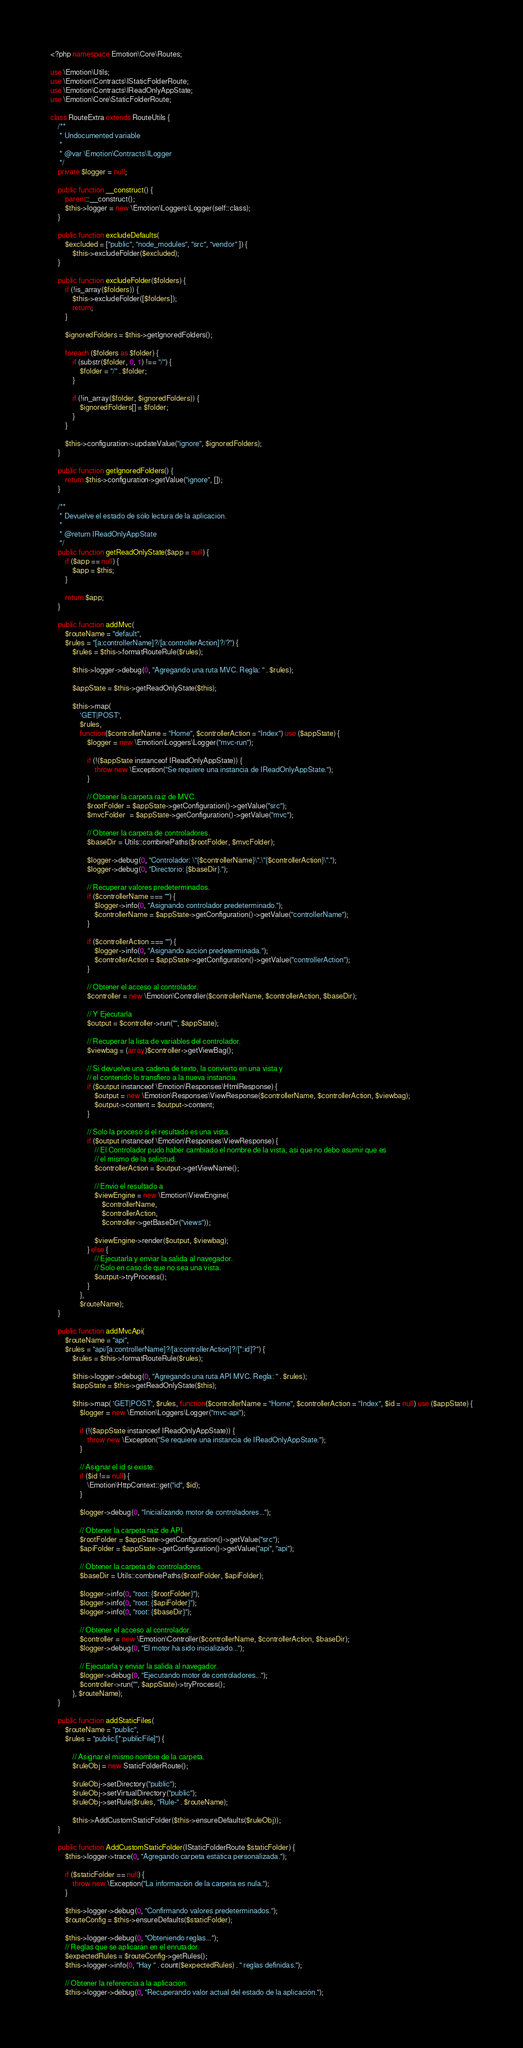<code> <loc_0><loc_0><loc_500><loc_500><_PHP_><?php namespace Emotion\Core\Routes;

use \Emotion\Utils;
use \Emotion\Contracts\IStaticFolderRoute;
use \Emotion\Contracts\IReadOnlyAppState;
use \Emotion\Core\StaticFolderRoute;

class RouteExtra extends RouteUtils {
    /**
     * Undocumented variable
     *
     * @var \Emotion\Contracts\ILogger
     */
    private $logger = null;

    public function __construct() {
        parent::__construct();
        $this->logger = new \Emotion\Loggers\Logger(self::class);
    }

    public function excludeDefaults(
        $excluded = ["public", "node_modules", "src", "vendor" ]) {
            $this->excludeFolder($excluded);
    }
    
    public function excludeFolder($folders) {
        if (!is_array($folders)) {
            $this->excludeFolder([$folders]);
            return;
        }
        
        $ignoredFolders = $this->getIgnoredFolders();
        
        foreach ($folders as $folder) {
            if (substr($folder, 0, 1) !== "/") {
                $folder = "/" . $folder;
            }
            
            if (!in_array($folder, $ignoredFolders)) {
                $ignoredFolders[] = $folder;
            }
        }
        
        $this->configuration->updateValue("ignore", $ignoredFolders);
    }
    
    public function getIgnoredFolders() {
        return $this->configuration->getValue("ignore", []);
    }

    /**
     * Devuelve el estado de sólo lectura de la aplicación.
     *
     * @return IReadOnlyAppState
     */
    public function getReadOnlyState($app = null) {
        if ($app == null) {
            $app = $this;
        }

        return $app;
    }
    
    public function addMvc(
        $routeName = "default",
        $rules = "[a:controllerName]?/[a:controllerAction]?/?") {
            $rules = $this->formatRouteRule($rules);

            $this->logger->debug(0, "Agregando una ruta MVC. Regla: " . $rules);

            $appState = $this->getReadOnlyState($this);

            $this->map(
                'GET|POST',
                $rules, 
                function($controllerName = "Home", $controllerAction = "Index") use ($appState) {
                    $logger = new \Emotion\Loggers\Logger("mvc-run");

                    if (!($appState instanceof IReadOnlyAppState)) {
                        throw new \Exception("Se requiere una instancia de IReadOnlyAppState.");
                    }

                    // Obtener la carpeta raíz de MVC.
                    $rootFolder = $appState->getConfiguration()->getValue("src");
                    $mvcFolder  = $appState->getConfiguration()->getValue("mvc");

                    // Obtener la carpeta de controladores.
                    $baseDir = Utils::combinePaths($rootFolder, $mvcFolder);

                    $logger->debug(0, "Controlador: \"{$controllerName}\".\"{$controllerAction}\".");
                    $logger->debug(0, "Directorio: {$baseDir}.");

                    // Recuperar valores predeterminados.
                    if ($controllerName === "") {
                        $logger->info(0, "Asignando controlador predeterminado.");
                        $controllerName = $appState->getConfiguration()->getValue("controllerName");
                    }

                    if ($controllerAction === "") {
                        $logger->info(0, "Asignando acción predeterminada.");
                        $controllerAction = $appState->getConfiguration()->getValue("controllerAction");
                    }

                    // Obtener el acceso al controlador.
                    $controller = new \Emotion\Controller($controllerName, $controllerAction, $baseDir);

                    // Y Ejecutarla
                    $output = $controller->run("", $appState);
                
                    // Recuperar la lista de variables del controlador.
                    $viewbag = (array)$controller->getViewBag();
                    
                    // Si devuelve una cadena de texto, la convierto en una vista y
                    // el contenido lo transfiero a la nueva instancia.
                    if ($output instanceof \Emotion\Responses\HtmlResponse) {
                        $output = new \Emotion\Responses\ViewResponse($controllerName, $controllerAction, $viewbag);
                        $output->content = $output->content;
                    }
                    
                    // Solo la proceso si el resultado es una vista.
                    if ($output instanceof \Emotion\Responses\ViewResponse) {
                        // El Controlador pudo haber cambiado el nombre de la vista, así que no debo asumir que es
                        // el mismo de la solicitud.
                        $controllerAction = $output->getViewName();

                        // Envio el resultado a 
                        $viewEngine = new \Emotion\ViewEngine(
                            $controllerName,
                            $controllerAction,
                            $controller->getBaseDir("views"));
                
                        $viewEngine->render($output, $viewbag);
                    } else {
                        // Ejecutarla y enviar la salida al navegador.
                        // Solo en caso de que no sea una vista.
                        $output->tryProcess();
                    }             
                },
                $routeName);
    }

    public function addMvcApi(
        $routeName = "api",
        $rules = "api/[a:controllerName]?/[a:controllerAction]?/[*:id]?") {
            $rules = $this->formatRouteRule($rules);

            $this->logger->debug(0, "Agregando una ruta API MVC. Regla: " . $rules);
            $appState = $this->getReadOnlyState($this);

            $this->map( 'GET|POST', $rules, function($controllerName = "Home", $controllerAction = "Index", $id = null) use ($appState) {
                $logger = new \Emotion\Loggers\Logger("mvc-api");
                
                if (!($appState instanceof IReadOnlyAppState)) {
                    throw new \Exception("Se requiere una instancia de IReadOnlyAppState.");
                }

                // Asignar el id si existe.
                if ($id !== null) {
                    \Emotion\HttpContext::get("id", $id);
                }

                $logger->debug(0, "Inicializando motor de controladores...");

                // Obtener la carpeta raíz de API.
                $rootFolder = $appState->getConfiguration()->getValue("src");
                $apiFolder = $appState->getConfiguration()->getValue("api", "api");

                // Obtener la carpeta de controladores.
                $baseDir = Utils::combinePaths($rootFolder, $apiFolder);

                $logger->info(0, "root: {$rootFolder}");
                $logger->info(0, "root: {$apiFolder}");
                $logger->info(0, "root: {$baseDir}");

                // Obtener el acceso al controlador.
                $controller = new \Emotion\Controller($controllerName, $controllerAction, $baseDir);
                $logger->debug(0, "El motor ha sido inicializado...");
            
                // Ejecutarla y enviar la salida al navegador.
                $logger->debug(0, "Ejecutando motor de controladores...");
                $controller->run("", $appState)->tryProcess();
            }, $routeName);
    }

    public function addStaticFiles(
        $routeName = "public", 
        $rules = "public/[*:publicFile]") {
        
            // Asignar el mismo nombre de la carpeta.
            $ruleObj = new StaticFolderRoute();

            $ruleObj->setDirectory("public");
            $ruleObj->setVirtualDirectory("public");
            $ruleObj->setRule($rules, "Rule-" . $routeName);
            
            $this->AddCustomStaticFolder($this->ensureDefaults($ruleObj));
    }
    
    public function AddCustomStaticFolder(IStaticFolderRoute $staticFolder) {
        $this->logger->trace(0, "Agregando carpeta estática personalizada.");
        
        if ($staticFolder == null) {
            throw new \Exception("La información de la carpeta es nula.");
        }
        
        $this->logger->debug(0, "Confirmando valores predeterminados.");
        $routeConfig = $this->ensureDefaults($staticFolder);
        
        $this->logger->debug(0, "Obteniendo reglas...");
        // Reglas que se aplicarán en el enrutador.
        $expectedRules = $routeConfig->getRules();
        $this->logger->info(0, "Hay " . count($expectedRules) . " reglas definidas.");
        
        // Obtener la referencia a la aplicación.
        $this->logger->debug(0, "Recuperando valor actual del estado de la aplicación.");</code> 